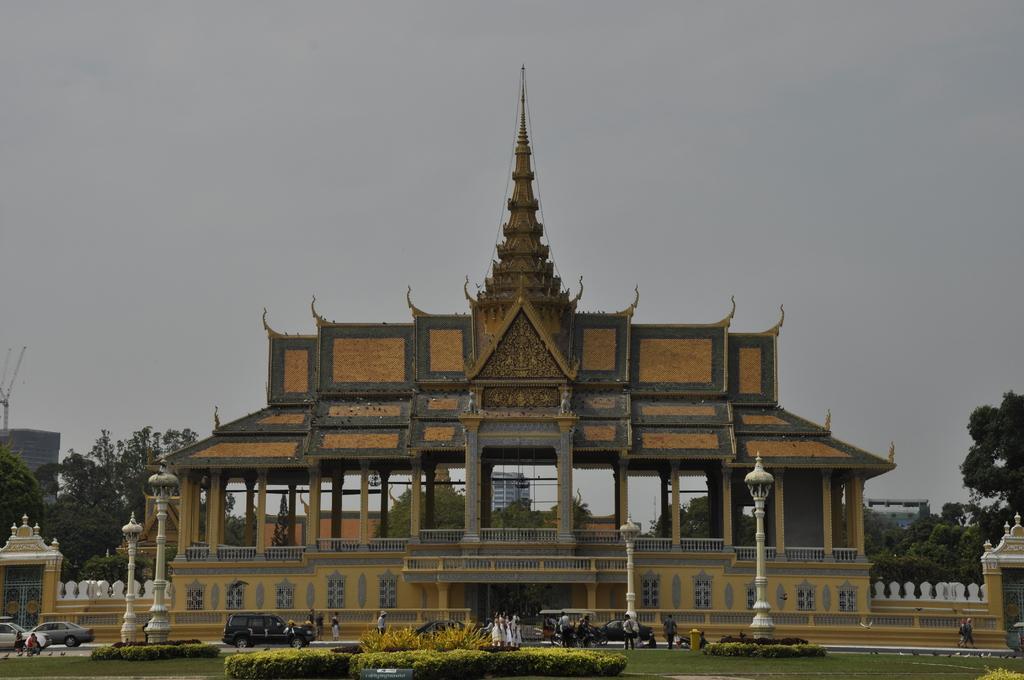In one or two sentences, can you explain what this image depicts? In this image I can see the ground, few plants on the ground, few white colored poles, few persons standing, few vehicles on the road and a huge building which is orange, black and cream in color. In the background I can see few buildings, few trees, a crane on the building and the sky. 